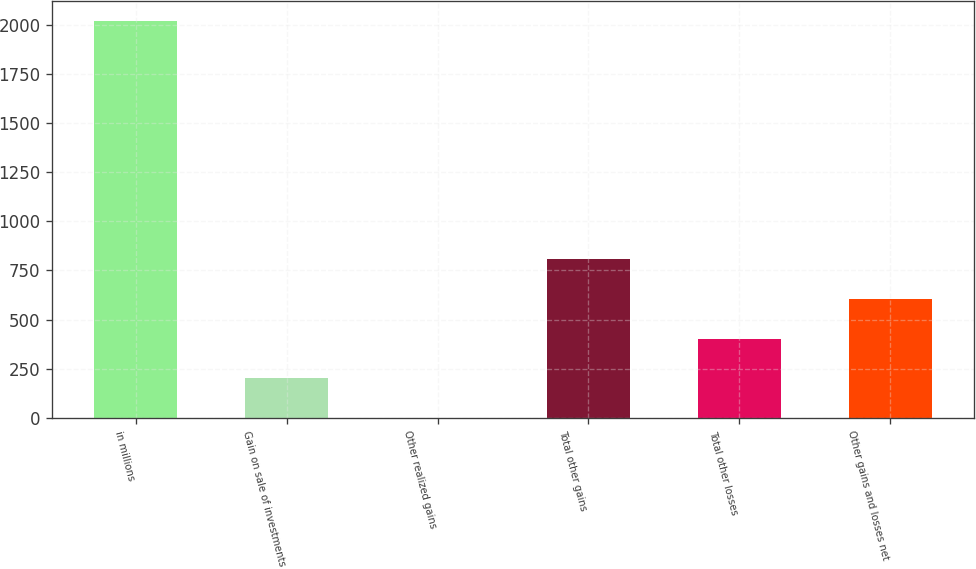<chart> <loc_0><loc_0><loc_500><loc_500><bar_chart><fcel>in millions<fcel>Gain on sale of investments<fcel>Other realized gains<fcel>Total other gains<fcel>Total other losses<fcel>Other gains and losses net<nl><fcel>2017<fcel>201.88<fcel>0.2<fcel>806.92<fcel>403.56<fcel>605.24<nl></chart> 